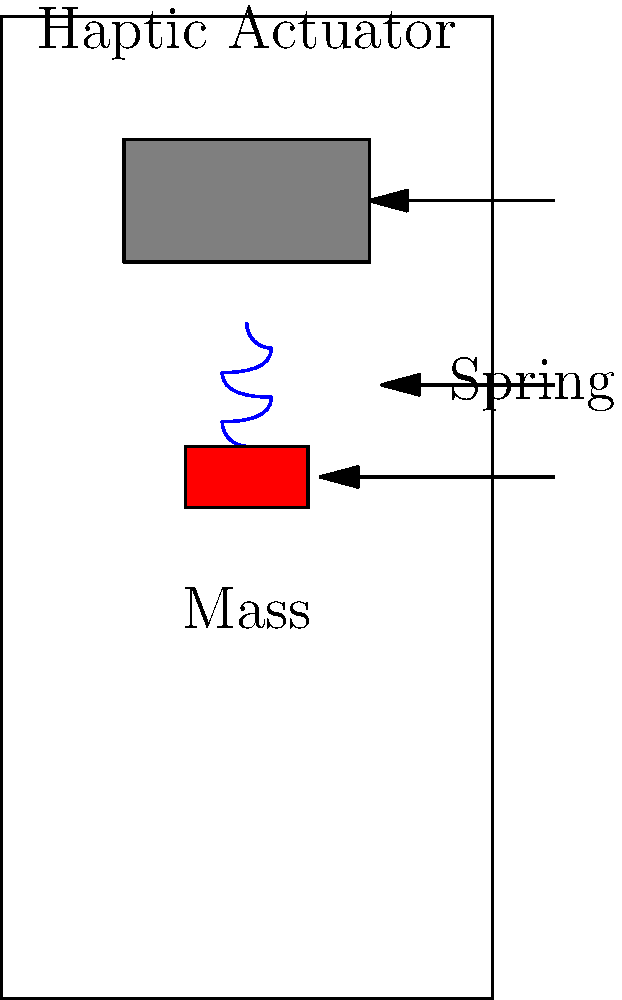In the context of haptic feedback for mobile devices used by visually impaired individuals, consider a simple mass-spring system as shown in the diagram. If the mass of the actuator is 5 grams and the spring constant is 200 N/m, what is the natural frequency of oscillation for this haptic feedback system? How might this frequency impact the user experience for individuals with visual impairments? To solve this problem and understand its implications, let's follow these steps:

1. Recall the formula for the natural frequency of a mass-spring system:
   $$f = \frac{1}{2\pi}\sqrt{\frac{k}{m}}$$
   Where:
   $f$ is the natural frequency in Hz
   $k$ is the spring constant in N/m
   $m$ is the mass in kg

2. Convert the given mass from grams to kilograms:
   5 grams = 0.005 kg

3. Substitute the values into the formula:
   $$f = \frac{1}{2\pi}\sqrt{\frac{200}{0.005}}$$

4. Calculate the result:
   $$f \approx 31.83 \text{ Hz}$$

5. Implications for visually impaired users:
   - This frequency falls within the range of human tactile perception (approximately 20-1000 Hz).
   - Lower frequencies (below 50 Hz) are generally perceived as separate pulses, which can be useful for conveying distinct information.
   - This frequency might be suitable for providing clear, distinguishable feedback without being too rapid or blending into a continuous sensation.
   - For visually impaired users, this could allow for the creation of tactile patterns or codes to represent different interface elements or actions.
   - However, individual sensitivity to vibrations varies, so customization options might be necessary to accommodate different users' needs.
Answer: 31.83 Hz; suitable for distinct tactile feedback, potentially allowing for coded information through vibration patterns. 